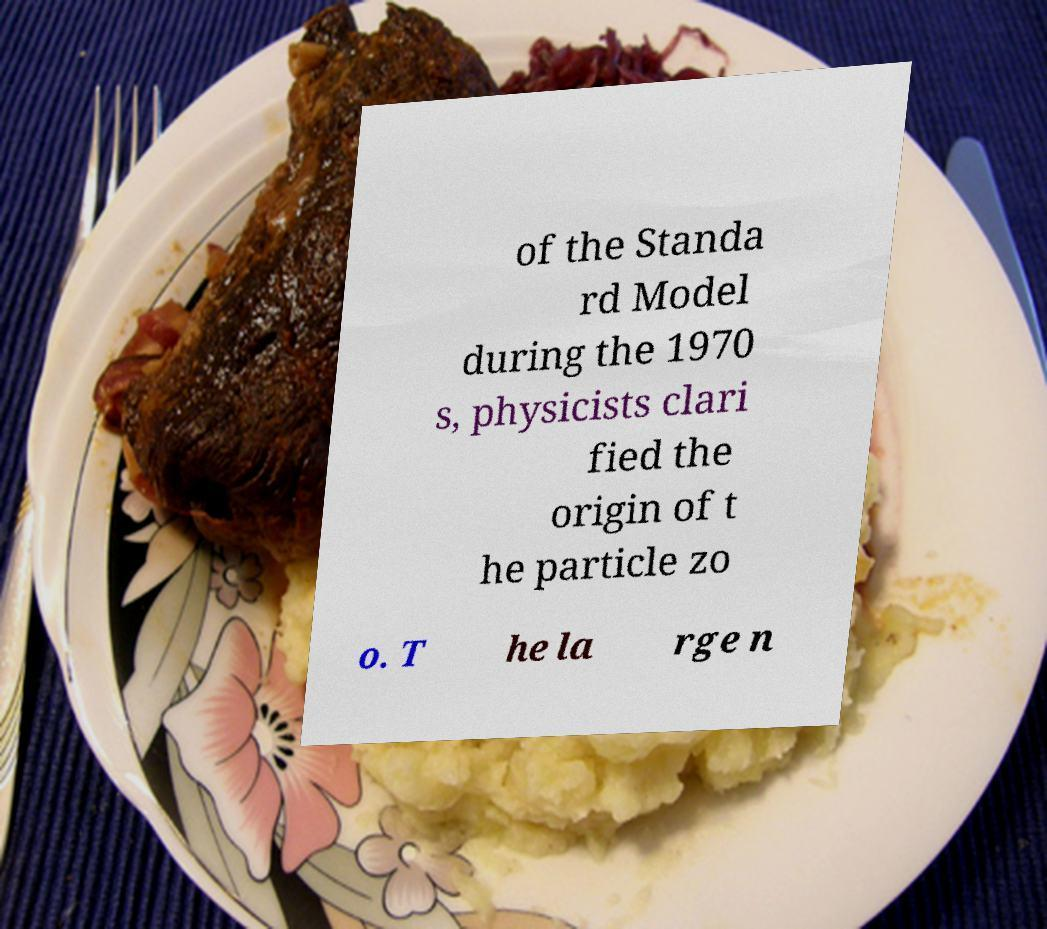Could you extract and type out the text from this image? of the Standa rd Model during the 1970 s, physicists clari fied the origin of t he particle zo o. T he la rge n 